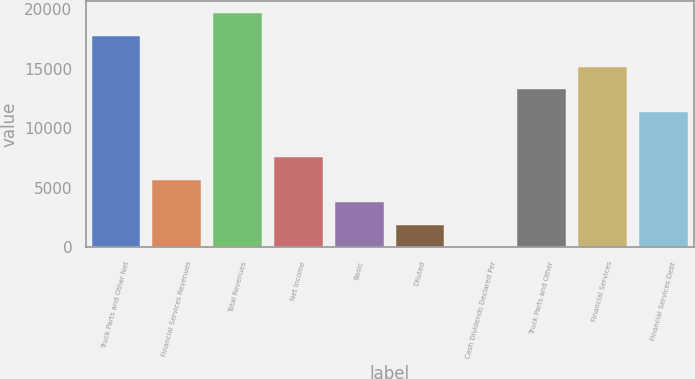<chart> <loc_0><loc_0><loc_500><loc_500><bar_chart><fcel>Truck Parts and Other Net<fcel>Financial Services Revenues<fcel>Total Revenues<fcel>Net Income<fcel>Basic<fcel>Diluted<fcel>Cash Dividends Declared Per<fcel>Truck Parts and Other<fcel>Financial Services<fcel>Financial Services Debt<nl><fcel>17792.8<fcel>5700.39<fcel>19692.3<fcel>7599.9<fcel>3800.88<fcel>1901.37<fcel>1.86<fcel>13298.4<fcel>15197.9<fcel>11398.9<nl></chart> 